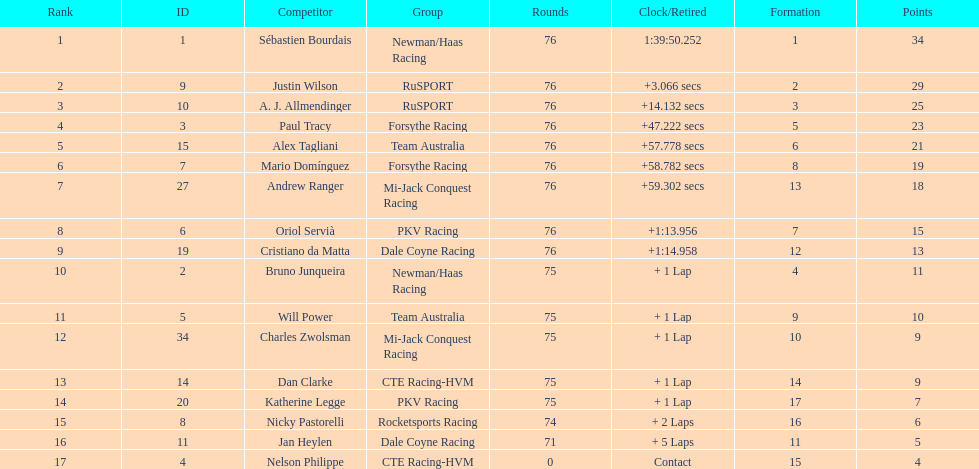What is the total point difference between the driver who received the most points and the driver who received the least? 30. 